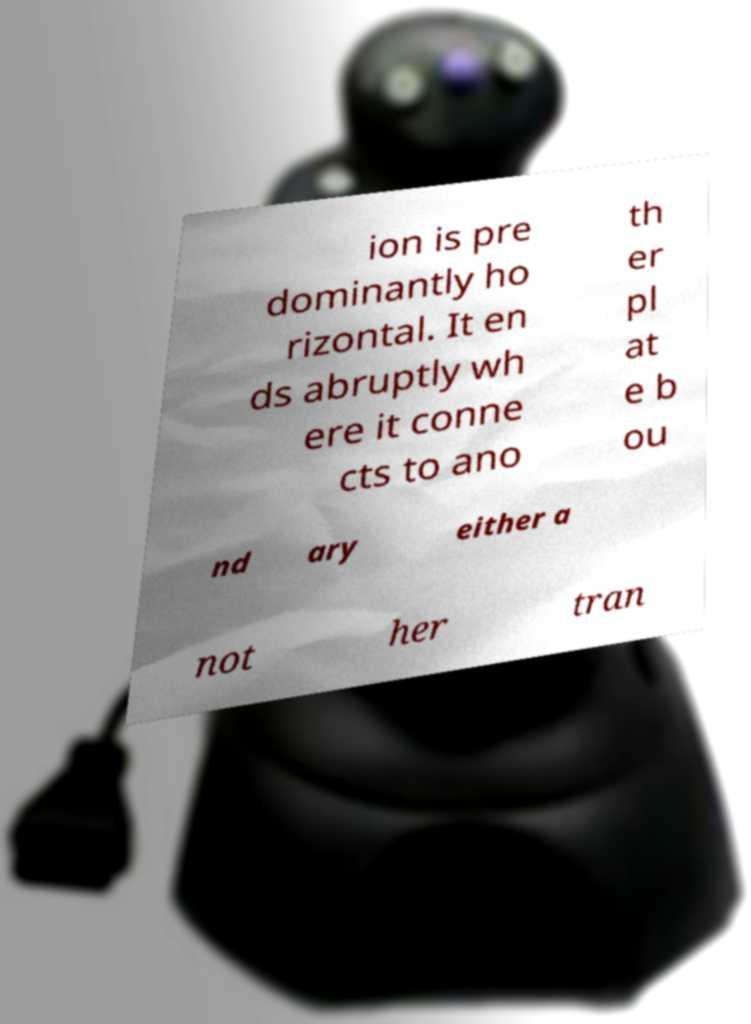Can you accurately transcribe the text from the provided image for me? ion is pre dominantly ho rizontal. It en ds abruptly wh ere it conne cts to ano th er pl at e b ou nd ary either a not her tran 